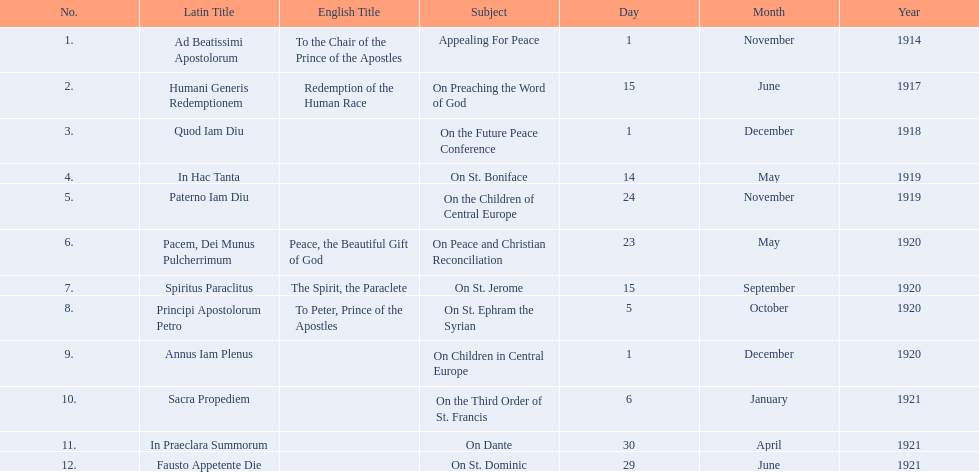What are all the subjects? Appealing For Peace, On Preaching the Word of God, On the Future Peace Conference, On St. Boniface, On the Children of Central Europe, On Peace and Christian Reconciliation, On St. Jerome, On St. Ephram the Syrian, On Children in Central Europe, On the Third Order of St. Francis, On Dante, On St. Dominic. What are their dates? 1 November 1914, 15 June 1917, 1 December 1918, 14 May 1919, 24 November 1919, 23 May 1920, 15 September 1920, 5 October 1920, 1 December 1920, 6 January 1921, 30 April 1921, 29 June 1921. Which subject's date belongs to 23 may 1920? On Peace and Christian Reconciliation. 